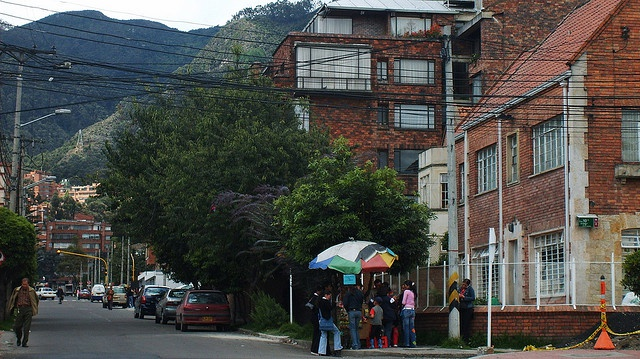Describe the objects in this image and their specific colors. I can see umbrella in lightgray, turquoise, purple, and teal tones, car in lightgray, black, maroon, gray, and navy tones, people in lightgray, black, maroon, and gray tones, people in lightgray, black, blue, navy, and gray tones, and people in lightgray, black, gray, navy, and maroon tones in this image. 